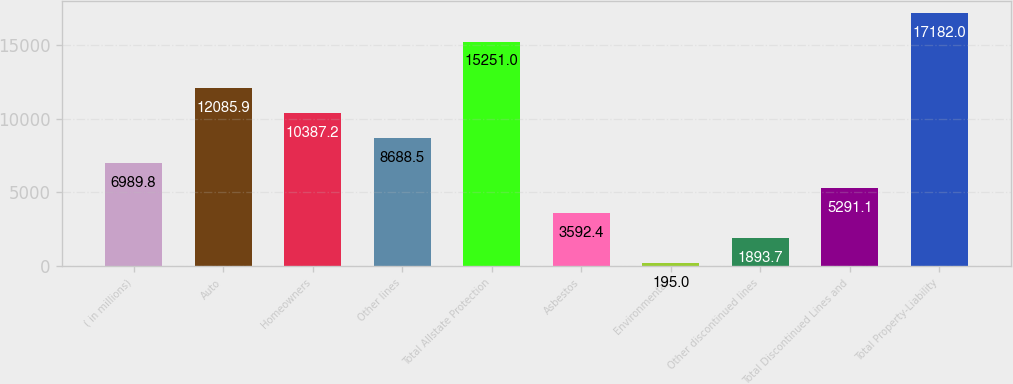Convert chart. <chart><loc_0><loc_0><loc_500><loc_500><bar_chart><fcel>( in millions)<fcel>Auto<fcel>Homeowners<fcel>Other lines<fcel>Total Allstate Protection<fcel>Asbestos<fcel>Environmental<fcel>Other discontinued lines<fcel>Total Discontinued Lines and<fcel>Total Property-Liability<nl><fcel>6989.8<fcel>12085.9<fcel>10387.2<fcel>8688.5<fcel>15251<fcel>3592.4<fcel>195<fcel>1893.7<fcel>5291.1<fcel>17182<nl></chart> 